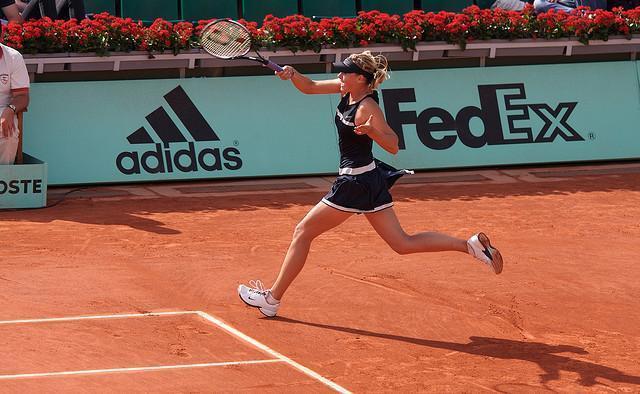How many people are in the photo?
Give a very brief answer. 2. 